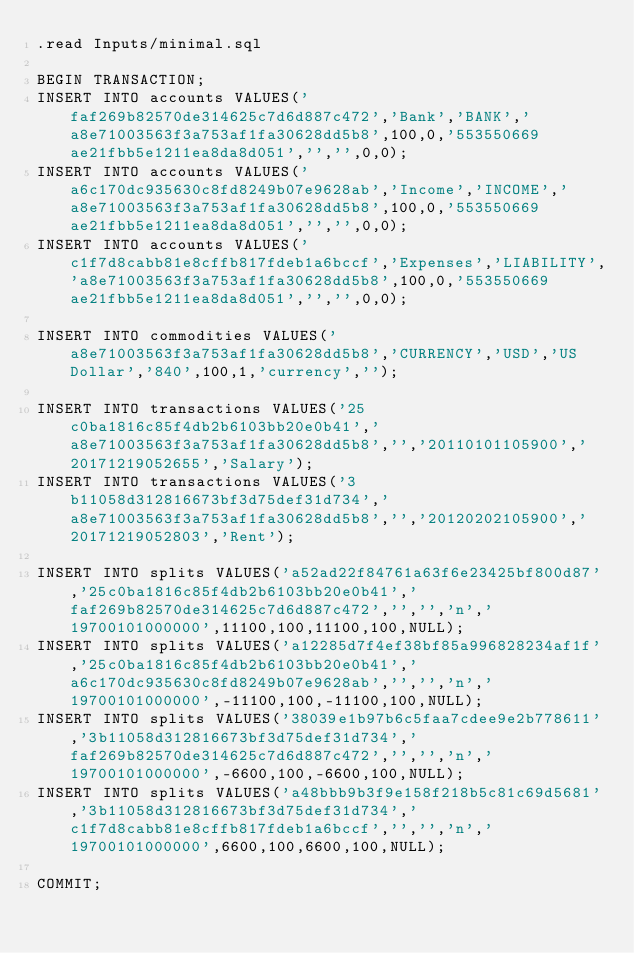<code> <loc_0><loc_0><loc_500><loc_500><_SQL_>.read Inputs/minimal.sql

BEGIN TRANSACTION;
INSERT INTO accounts VALUES('faf269b82570de314625c7d6d887c472','Bank','BANK','a8e71003563f3a753af1fa30628dd5b8',100,0,'553550669ae21fbb5e1211ea8da8d051','','',0,0);
INSERT INTO accounts VALUES('a6c170dc935630c8fd8249b07e9628ab','Income','INCOME','a8e71003563f3a753af1fa30628dd5b8',100,0,'553550669ae21fbb5e1211ea8da8d051','','',0,0);
INSERT INTO accounts VALUES('c1f7d8cabb81e8cffb817fdeb1a6bccf','Expenses','LIABILITY','a8e71003563f3a753af1fa30628dd5b8',100,0,'553550669ae21fbb5e1211ea8da8d051','','',0,0);

INSERT INTO commodities VALUES('a8e71003563f3a753af1fa30628dd5b8','CURRENCY','USD','US Dollar','840',100,1,'currency','');

INSERT INTO transactions VALUES('25c0ba1816c85f4db2b6103bb20e0b41','a8e71003563f3a753af1fa30628dd5b8','','20110101105900','20171219052655','Salary');
INSERT INTO transactions VALUES('3b11058d312816673bf3d75def31d734','a8e71003563f3a753af1fa30628dd5b8','','20120202105900','20171219052803','Rent');

INSERT INTO splits VALUES('a52ad22f84761a63f6e23425bf800d87','25c0ba1816c85f4db2b6103bb20e0b41','faf269b82570de314625c7d6d887c472','','','n','19700101000000',11100,100,11100,100,NULL);
INSERT INTO splits VALUES('a12285d7f4ef38bf85a996828234af1f','25c0ba1816c85f4db2b6103bb20e0b41','a6c170dc935630c8fd8249b07e9628ab','','','n','19700101000000',-11100,100,-11100,100,NULL);
INSERT INTO splits VALUES('38039e1b97b6c5faa7cdee9e2b778611','3b11058d312816673bf3d75def31d734','faf269b82570de314625c7d6d887c472','','','n','19700101000000',-6600,100,-6600,100,NULL);
INSERT INTO splits VALUES('a48bbb9b3f9e158f218b5c81c69d5681','3b11058d312816673bf3d75def31d734','c1f7d8cabb81e8cffb817fdeb1a6bccf','','','n','19700101000000',6600,100,6600,100,NULL);

COMMIT;
</code> 